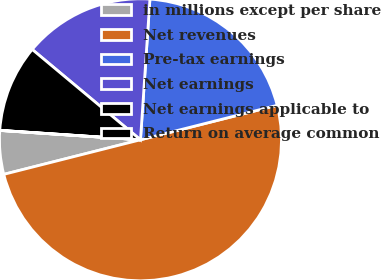Convert chart. <chart><loc_0><loc_0><loc_500><loc_500><pie_chart><fcel>in millions except per share<fcel>Net revenues<fcel>Pre-tax earnings<fcel>Net earnings<fcel>Net earnings applicable to<fcel>Return on average common<nl><fcel>5.0%<fcel>49.99%<fcel>20.0%<fcel>15.0%<fcel>10.0%<fcel>0.01%<nl></chart> 